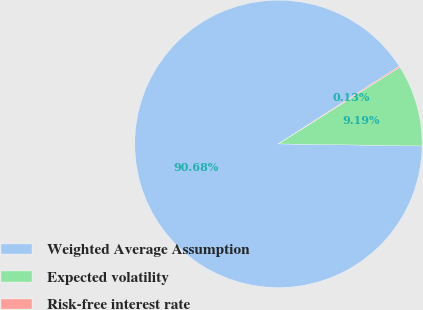Convert chart. <chart><loc_0><loc_0><loc_500><loc_500><pie_chart><fcel>Weighted Average Assumption<fcel>Expected volatility<fcel>Risk-free interest rate<nl><fcel>90.68%<fcel>9.19%<fcel>0.13%<nl></chart> 